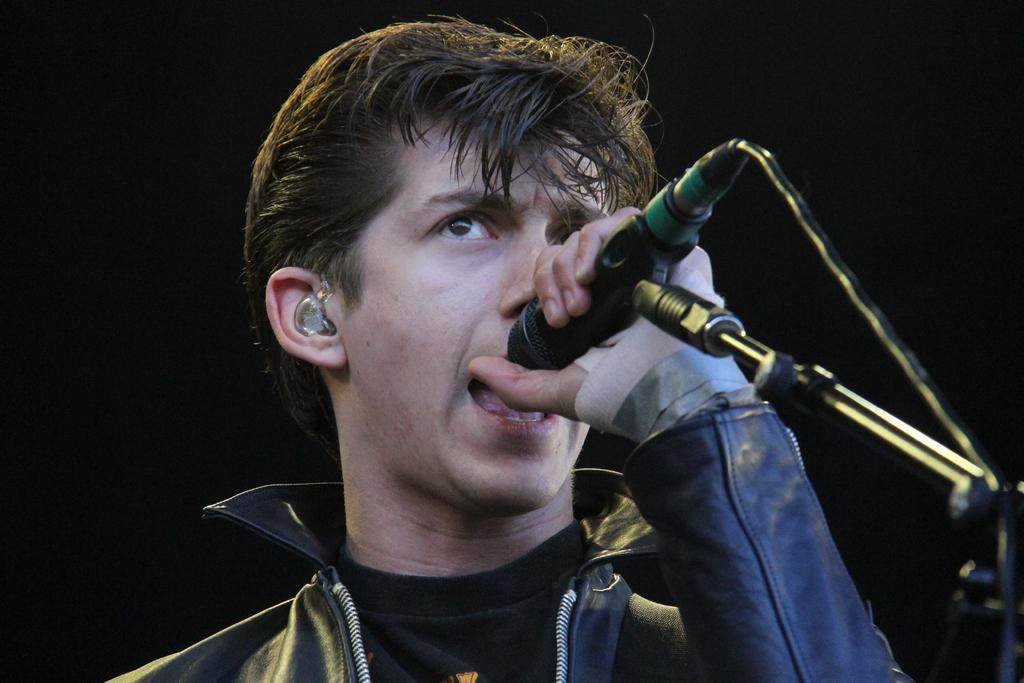What is the main subject of the image? There is a person in the image. What is the person wearing? The person is wearing a black dress. What is the person holding in the image? The person is holding a mic. What color is the background of the image? The background of the image is black. Can you tell me how many hens are visible in the image? There are no hens present in the image; it features a person holding a mic against a black background. What type of mark is on the person's face in the image? There is no mark visible on the person's face in the image. 